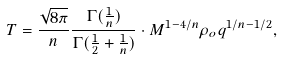<formula> <loc_0><loc_0><loc_500><loc_500>T = \frac { \sqrt { 8 \pi } } { n } \frac { \Gamma ( \frac { 1 } { n } ) } { \Gamma ( \frac { 1 } { 2 } + \frac { 1 } { n } ) } \cdot M ^ { 1 - 4 / n } \rho _ { o } q ^ { 1 / n - 1 / 2 } ,</formula> 